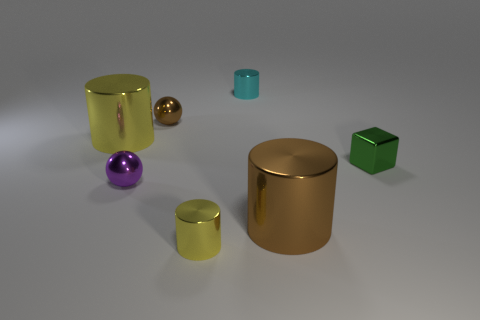Subtract all tiny cyan metal cylinders. How many cylinders are left? 3 Subtract all red cubes. How many yellow cylinders are left? 2 Subtract all brown cylinders. How many cylinders are left? 3 Add 2 small blocks. How many objects exist? 9 Subtract all purple cylinders. Subtract all red spheres. How many cylinders are left? 4 Subtract all cubes. How many objects are left? 6 Subtract all large purple things. Subtract all tiny purple metallic objects. How many objects are left? 6 Add 6 cubes. How many cubes are left? 7 Add 7 tiny cyan things. How many tiny cyan things exist? 8 Subtract 0 blue cubes. How many objects are left? 7 